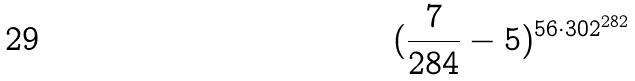<formula> <loc_0><loc_0><loc_500><loc_500>( \frac { 7 } { 2 8 4 } - 5 ) ^ { 5 6 \cdot 3 0 2 ^ { 2 8 2 } }</formula> 